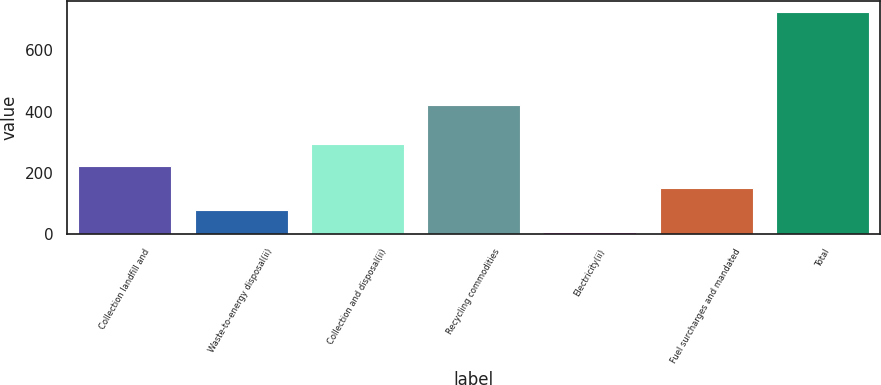Convert chart to OTSL. <chart><loc_0><loc_0><loc_500><loc_500><bar_chart><fcel>Collection landfill and<fcel>Waste-to-energy disposal(ii)<fcel>Collection and disposal(ii)<fcel>Recycling commodities<fcel>Electricity(ii)<fcel>Fuel surcharges and mandated<fcel>Total<nl><fcel>222.1<fcel>78.7<fcel>293.8<fcel>423<fcel>7<fcel>150.4<fcel>724<nl></chart> 